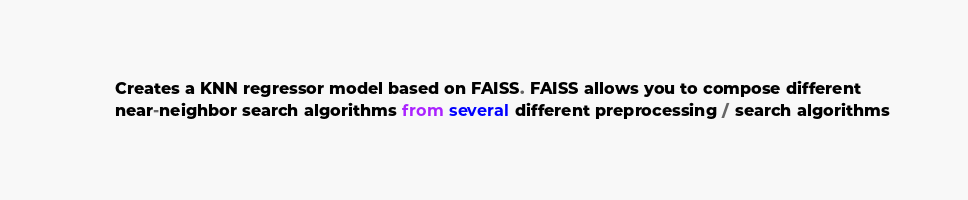<code> <loc_0><loc_0><loc_500><loc_500><_Python_>        Creates a KNN regressor model based on FAISS. FAISS allows you to compose different
        near-neighbor search algorithms from several different preprocessing / search algorithms</code> 